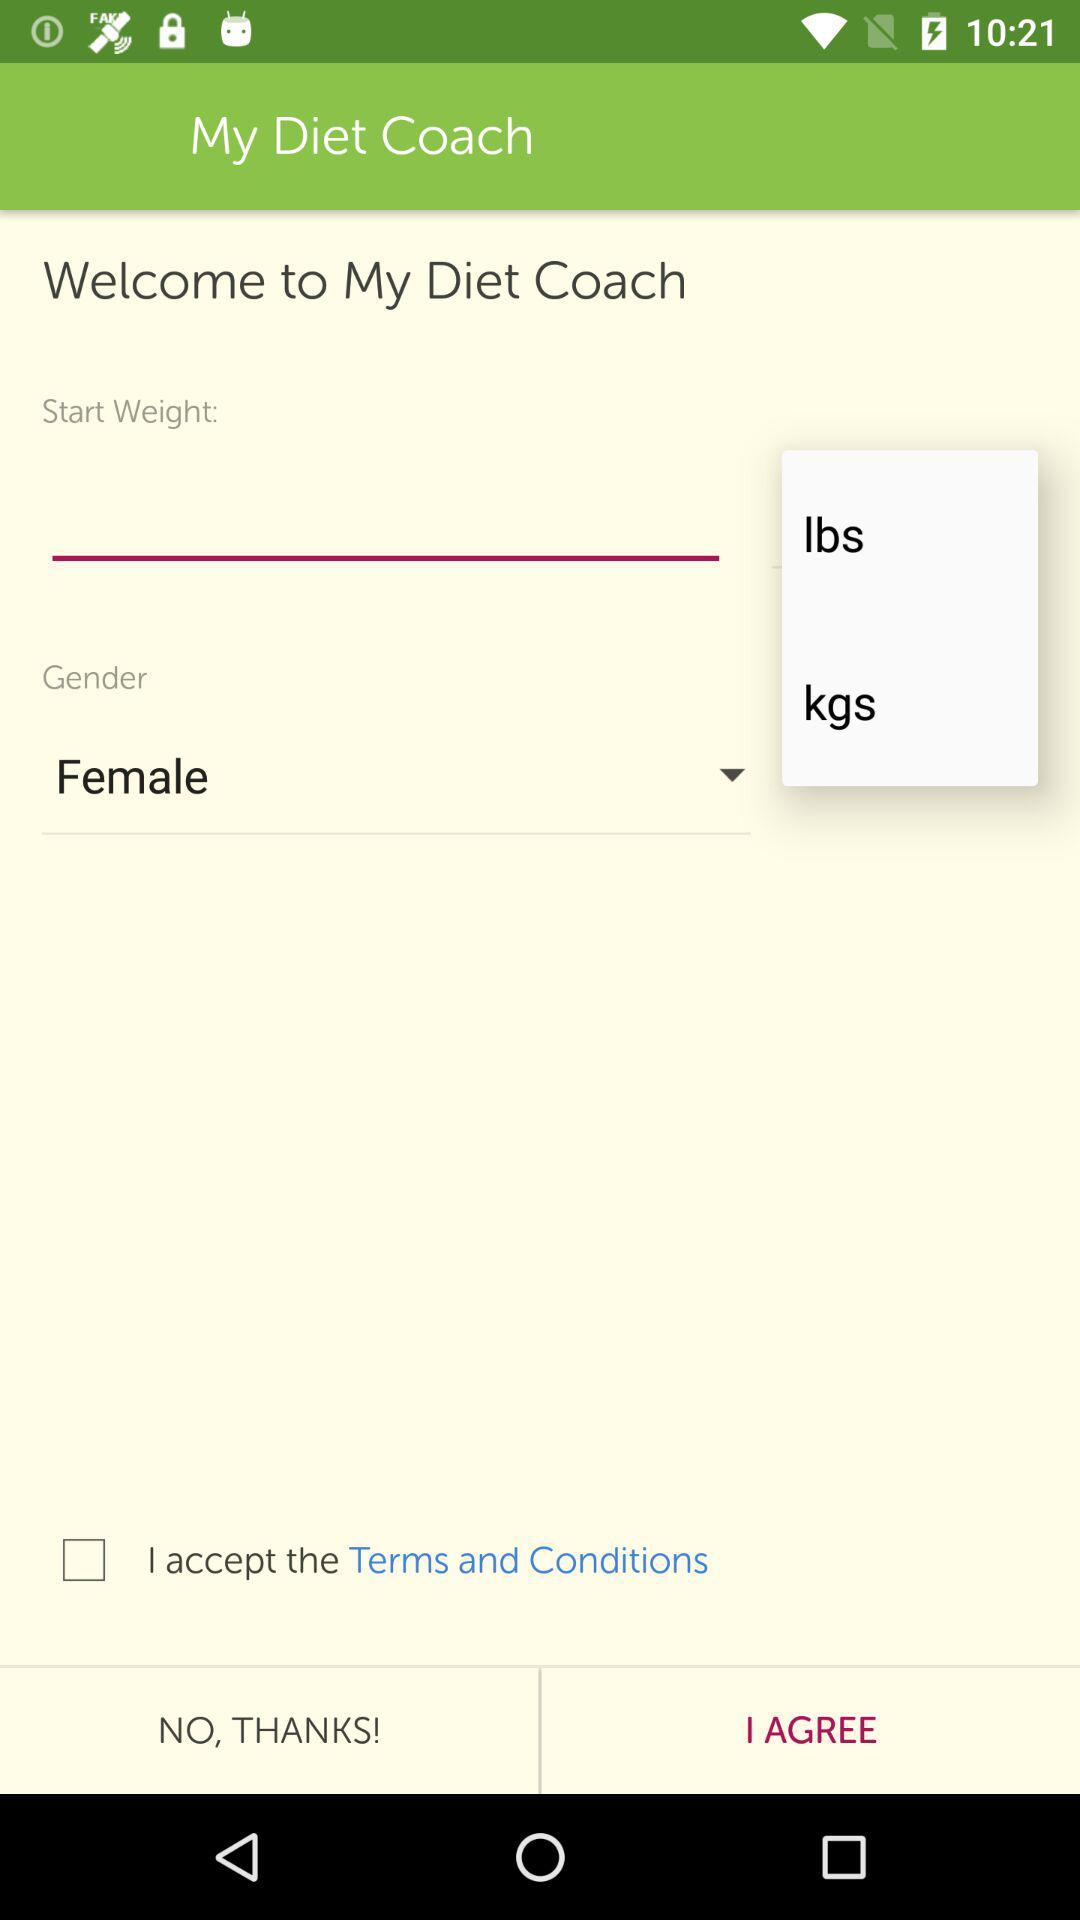What is the gender of the user? The gender of the user is female. 